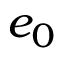<formula> <loc_0><loc_0><loc_500><loc_500>e _ { 0 }</formula> 